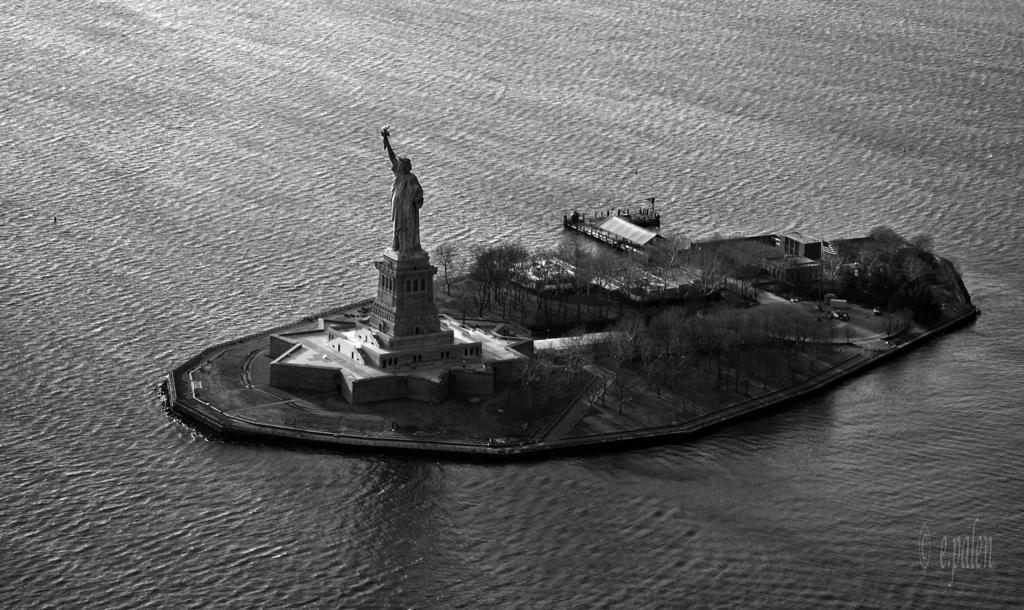Describe this image in one or two sentences. In this picture we can see statue of liberty. Here we can see an island on which we can see buildings, trees, grass, vehicles and road. On the bottom right corner there is a watermark. Around the island we can see water. 